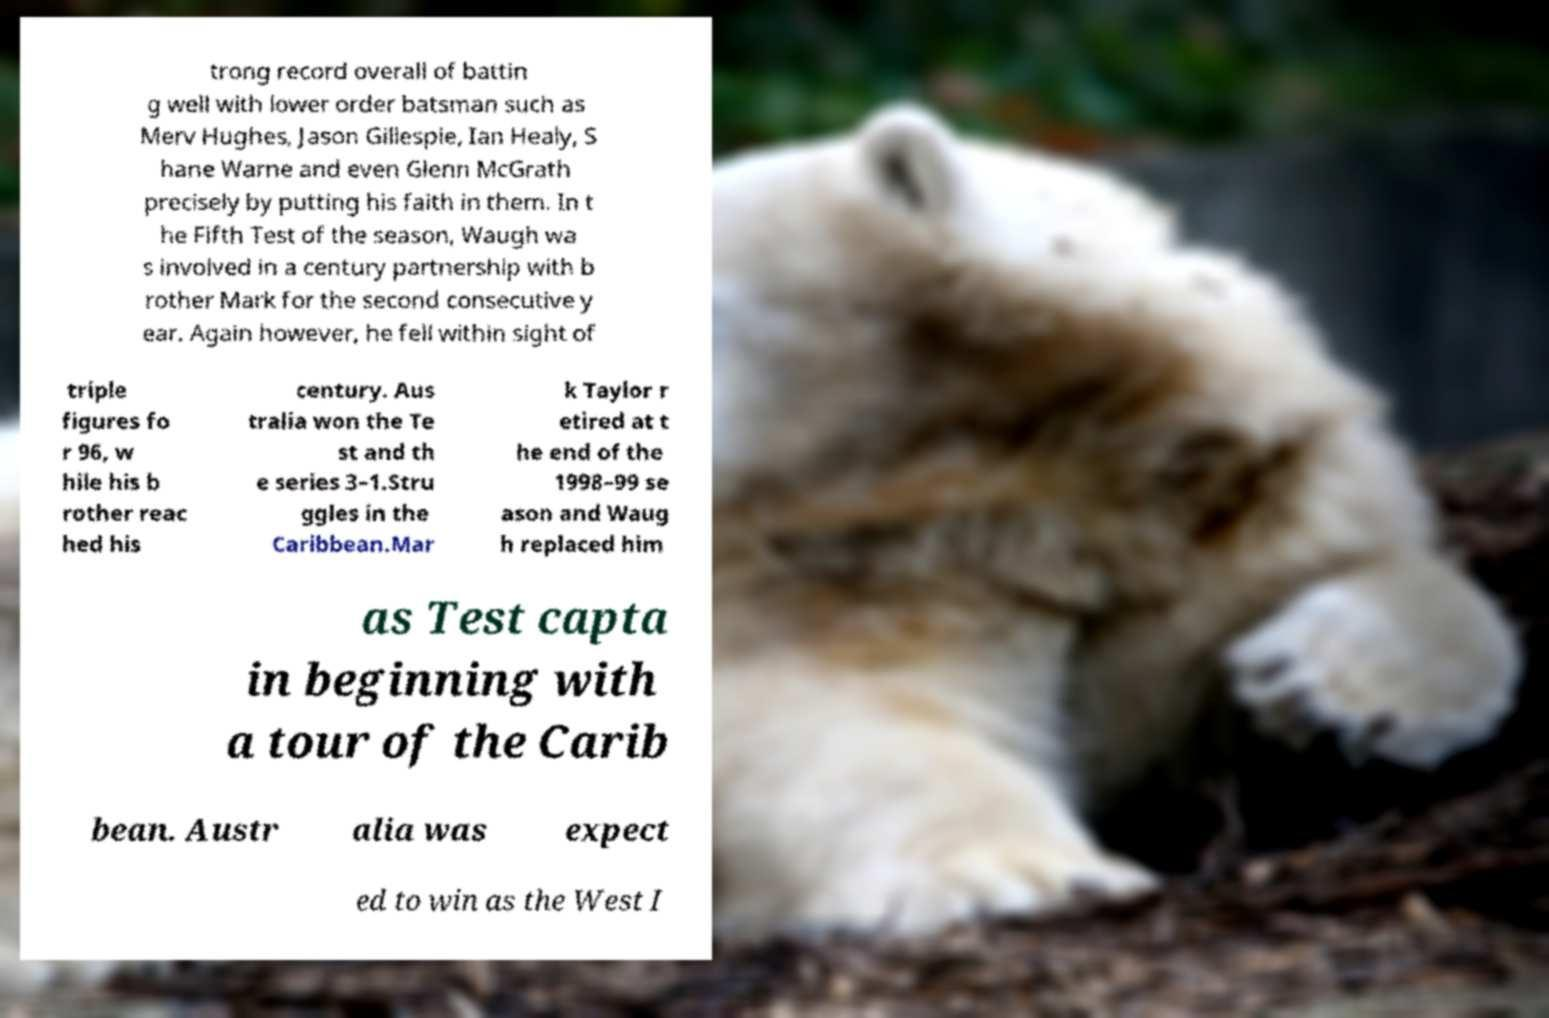Please read and relay the text visible in this image. What does it say? trong record overall of battin g well with lower order batsman such as Merv Hughes, Jason Gillespie, Ian Healy, S hane Warne and even Glenn McGrath precisely by putting his faith in them. In t he Fifth Test of the season, Waugh wa s involved in a century partnership with b rother Mark for the second consecutive y ear. Again however, he fell within sight of triple figures fo r 96, w hile his b rother reac hed his century. Aus tralia won the Te st and th e series 3–1.Stru ggles in the Caribbean.Mar k Taylor r etired at t he end of the 1998–99 se ason and Waug h replaced him as Test capta in beginning with a tour of the Carib bean. Austr alia was expect ed to win as the West I 